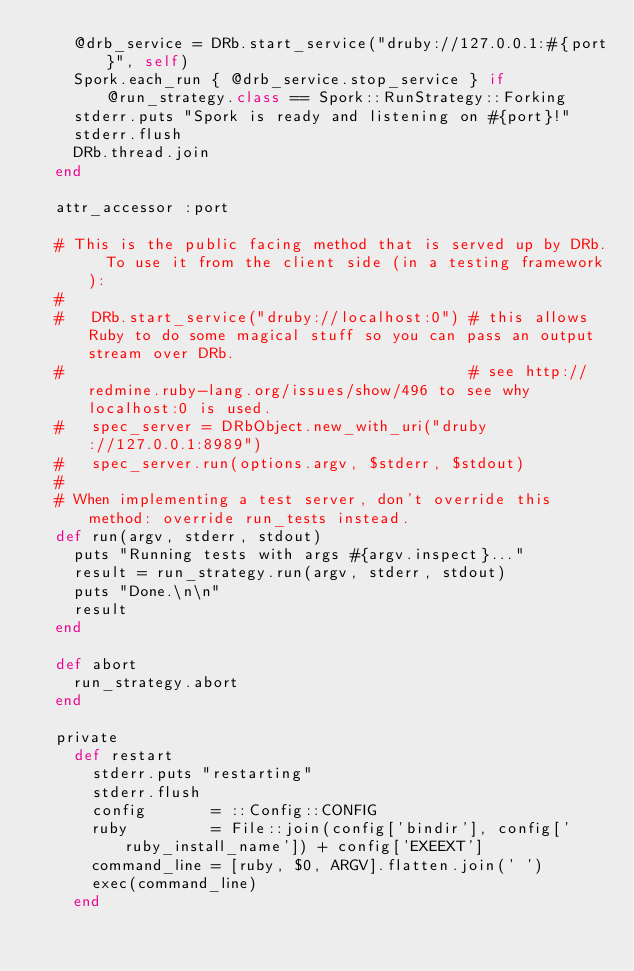Convert code to text. <code><loc_0><loc_0><loc_500><loc_500><_Ruby_>    @drb_service = DRb.start_service("druby://127.0.0.1:#{port}", self)
    Spork.each_run { @drb_service.stop_service } if @run_strategy.class == Spork::RunStrategy::Forking
    stderr.puts "Spork is ready and listening on #{port}!"
    stderr.flush
    DRb.thread.join
  end
  
  attr_accessor :port

  # This is the public facing method that is served up by DRb.  To use it from the client side (in a testing framework):
  # 
  #   DRb.start_service("druby://localhost:0") # this allows Ruby to do some magical stuff so you can pass an output stream over DRb.
  #                                            # see http://redmine.ruby-lang.org/issues/show/496 to see why localhost:0 is used.
  #   spec_server = DRbObject.new_with_uri("druby://127.0.0.1:8989")
  #   spec_server.run(options.argv, $stderr, $stdout)
  #
  # When implementing a test server, don't override this method: override run_tests instead.
  def run(argv, stderr, stdout)
    puts "Running tests with args #{argv.inspect}..."
    result = run_strategy.run(argv, stderr, stdout)
    puts "Done.\n\n"
    result
  end
  
  def abort
    run_strategy.abort
  end

  private
    def restart
      stderr.puts "restarting"
      stderr.flush
      config       = ::Config::CONFIG
      ruby         = File::join(config['bindir'], config['ruby_install_name']) + config['EXEEXT']
      command_line = [ruby, $0, ARGV].flatten.join(' ')
      exec(command_line)
    end
    </code> 